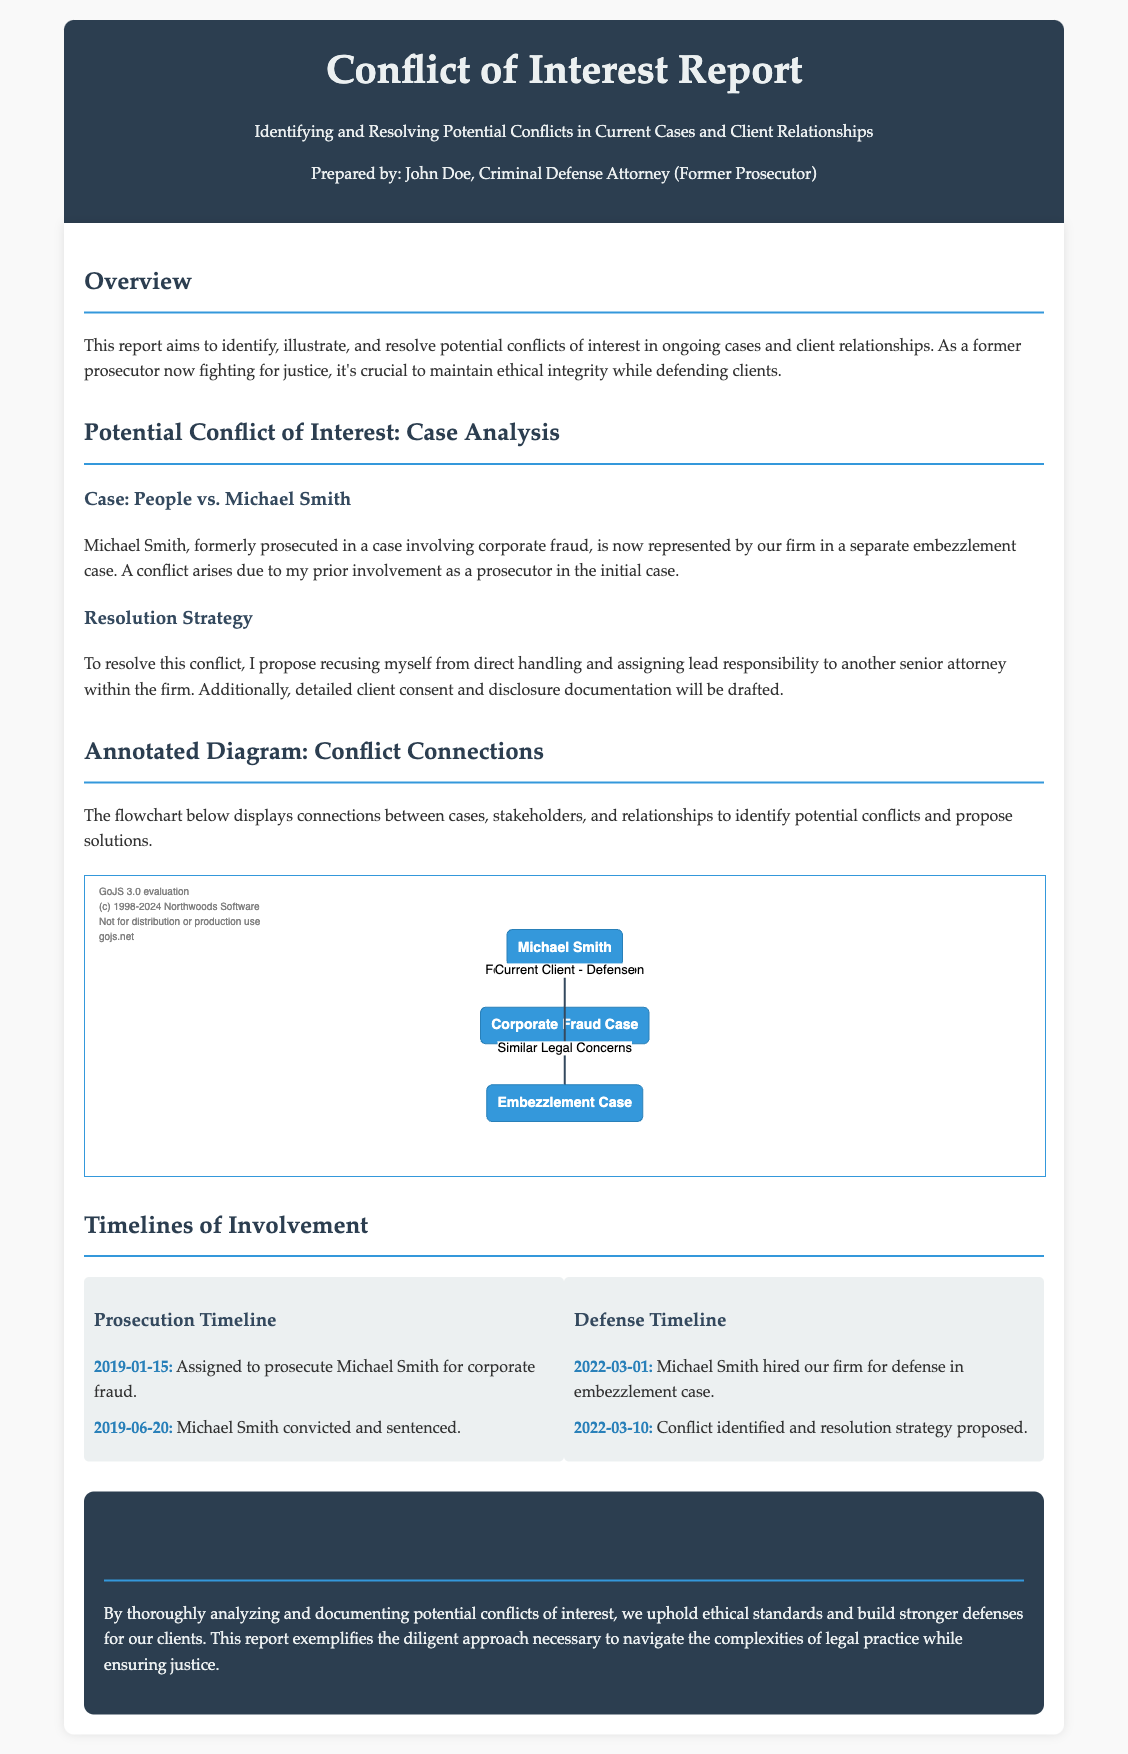What is the title of the report? The title is prominently displayed at the top of the document, identifying the main focus of the content.
Answer: Conflict of Interest Report Who prepared the report? The report includes the author's name and title in the header section, attributing the work to a specific individual.
Answer: John Doe, Criminal Defense Attorney (Former Prosecutor) What is the first case analyzed in the report? The report details a specific case that serves as an example of potential conflict, which is outlined clearly in the case analysis section.
Answer: People vs. Michael Smith What conflict resolution strategy is proposed? The content outlines a specific approach to address the identified conflict, emphasizing actions to take to maintain ethical integrity.
Answer: Recusing from direct handling and assigning lead responsibility What year was Michael Smith convicted? The timeline documents specific events related to the case, including the date of conviction.
Answer: 2019 How many events are listed in the Prosecution Timeline? The timeline section indicates the number of significant events that are crucial to understanding the case history.
Answer: 2 What color is the flowchart border? The visual design of the flowchart is specifically mentioned, indicating the chosen color scheme for presentation purposes.
Answer: Blue What does the conclusion emphasize? The concluding section summarizes the report's objectives and intentions, reinforcing the importance of the analyzed information.
Answer: Upholding ethical standards What is illustrated in the annotated diagram? The report provides insight into the purpose of the diagram, indicating its role in visualizing connections related to conflicts of interest.
Answer: Conflict connections 